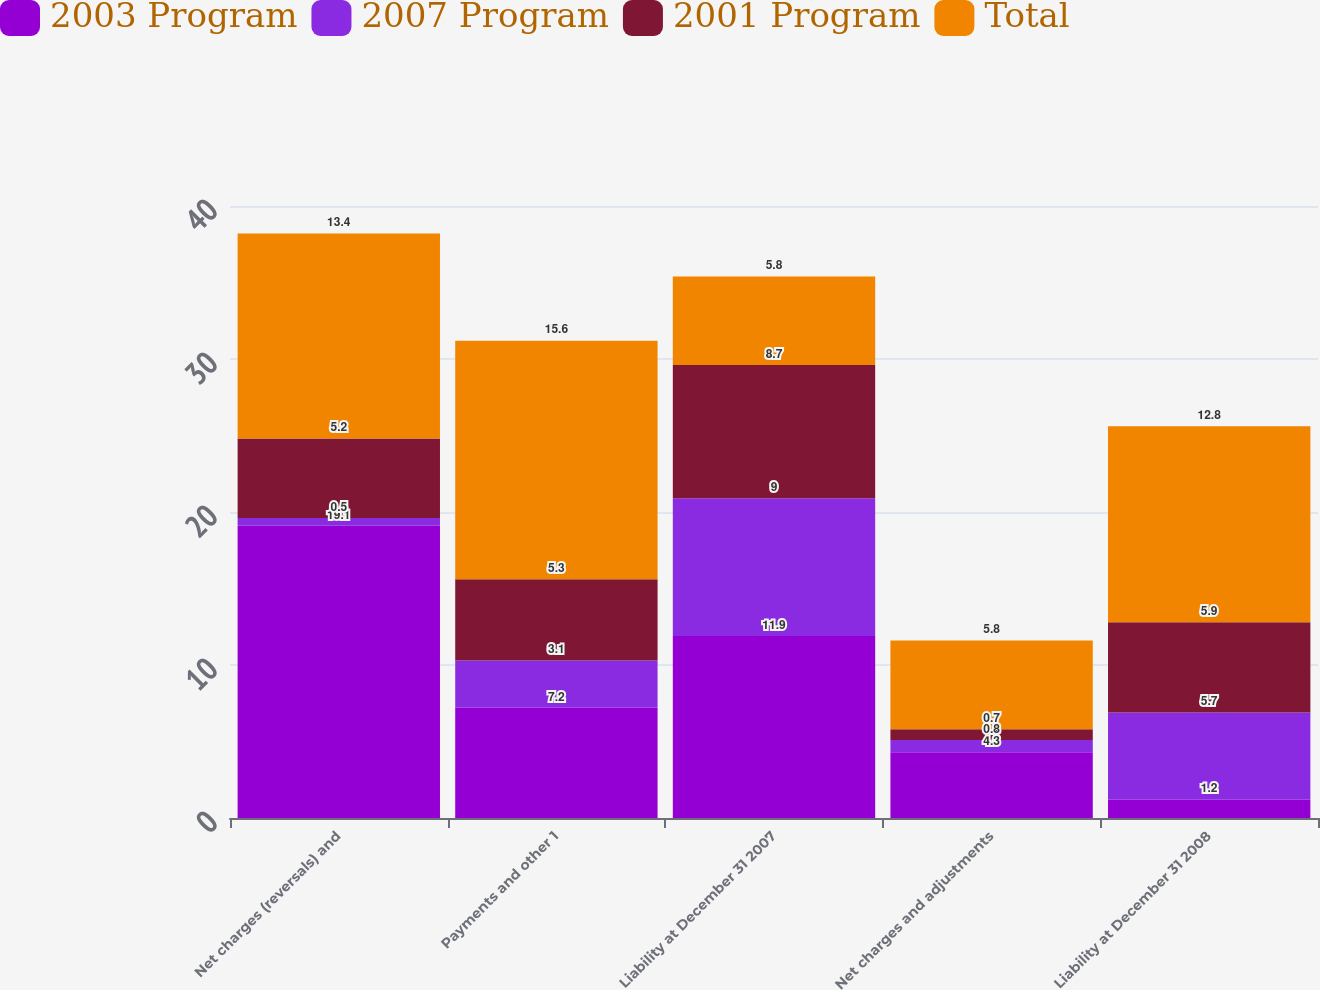<chart> <loc_0><loc_0><loc_500><loc_500><stacked_bar_chart><ecel><fcel>Net charges (reversals) and<fcel>Payments and other 1<fcel>Liability at December 31 2007<fcel>Net charges and adjustments<fcel>Liability at December 31 2008<nl><fcel>2003 Program<fcel>19.1<fcel>7.2<fcel>11.9<fcel>4.3<fcel>1.2<nl><fcel>2007 Program<fcel>0.5<fcel>3.1<fcel>9<fcel>0.8<fcel>5.7<nl><fcel>2001 Program<fcel>5.2<fcel>5.3<fcel>8.7<fcel>0.7<fcel>5.9<nl><fcel>Total<fcel>13.4<fcel>15.6<fcel>5.8<fcel>5.8<fcel>12.8<nl></chart> 